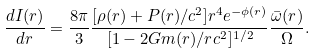Convert formula to latex. <formula><loc_0><loc_0><loc_500><loc_500>\frac { d I ( r ) } { d r } = \frac { 8 \pi } { 3 } \frac { [ \rho ( r ) + P ( r ) / c ^ { 2 } ] r ^ { 4 } e ^ { - \phi ( r ) } } { [ 1 - 2 G m ( r ) / r c ^ { 2 } ] ^ { 1 / 2 } } \frac { \bar { \omega } ( r ) } { \Omega } .</formula> 